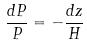Convert formula to latex. <formula><loc_0><loc_0><loc_500><loc_500>\frac { d P } { P } = - \frac { d z } { H }</formula> 